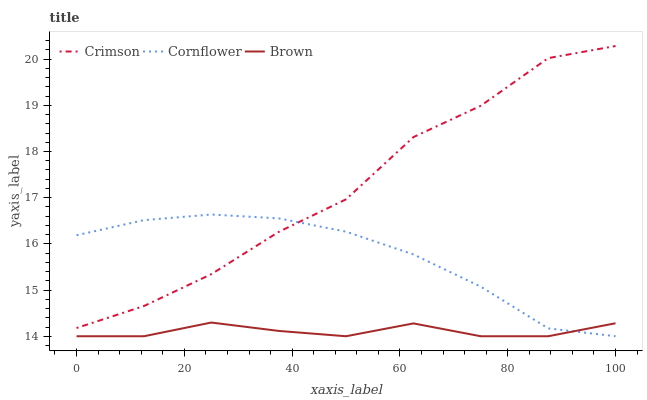Does Brown have the minimum area under the curve?
Answer yes or no. Yes. Does Crimson have the maximum area under the curve?
Answer yes or no. Yes. Does Cornflower have the minimum area under the curve?
Answer yes or no. No. Does Cornflower have the maximum area under the curve?
Answer yes or no. No. Is Cornflower the smoothest?
Answer yes or no. Yes. Is Crimson the roughest?
Answer yes or no. Yes. Is Brown the smoothest?
Answer yes or no. No. Is Brown the roughest?
Answer yes or no. No. Does Cornflower have the lowest value?
Answer yes or no. Yes. Does Crimson have the highest value?
Answer yes or no. Yes. Does Cornflower have the highest value?
Answer yes or no. No. Is Brown less than Crimson?
Answer yes or no. Yes. Is Crimson greater than Brown?
Answer yes or no. Yes. Does Cornflower intersect Crimson?
Answer yes or no. Yes. Is Cornflower less than Crimson?
Answer yes or no. No. Is Cornflower greater than Crimson?
Answer yes or no. No. Does Brown intersect Crimson?
Answer yes or no. No. 